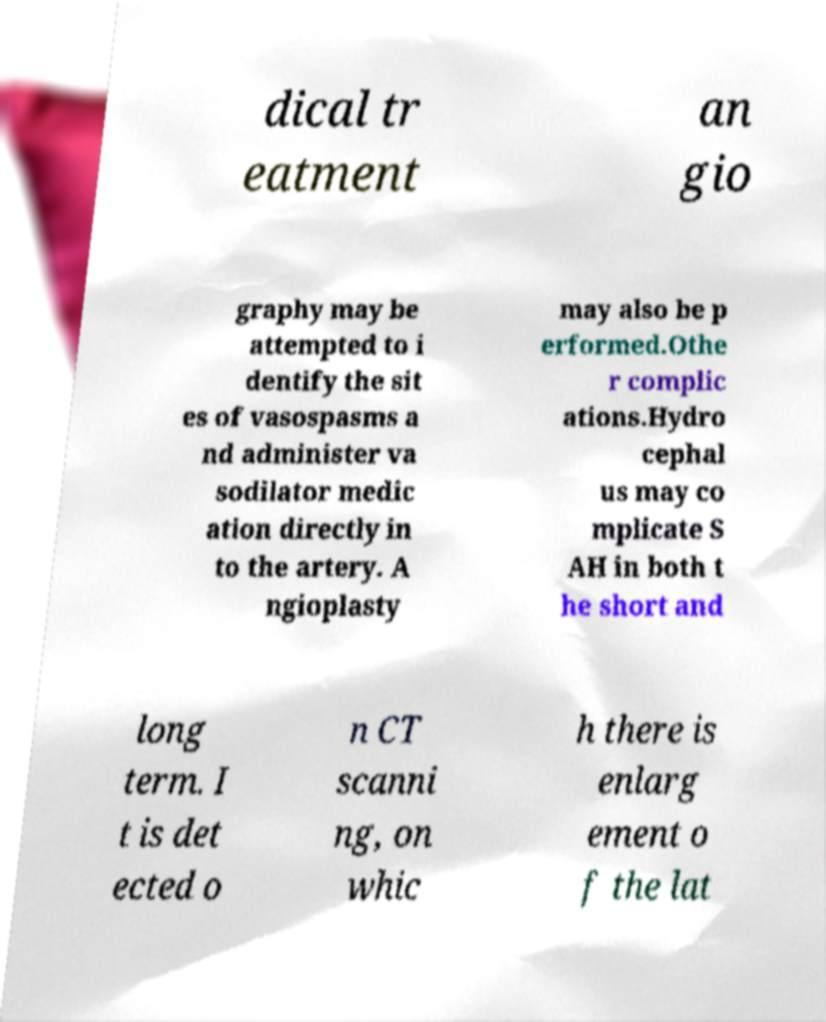There's text embedded in this image that I need extracted. Can you transcribe it verbatim? dical tr eatment an gio graphy may be attempted to i dentify the sit es of vasospasms a nd administer va sodilator medic ation directly in to the artery. A ngioplasty may also be p erformed.Othe r complic ations.Hydro cephal us may co mplicate S AH in both t he short and long term. I t is det ected o n CT scanni ng, on whic h there is enlarg ement o f the lat 